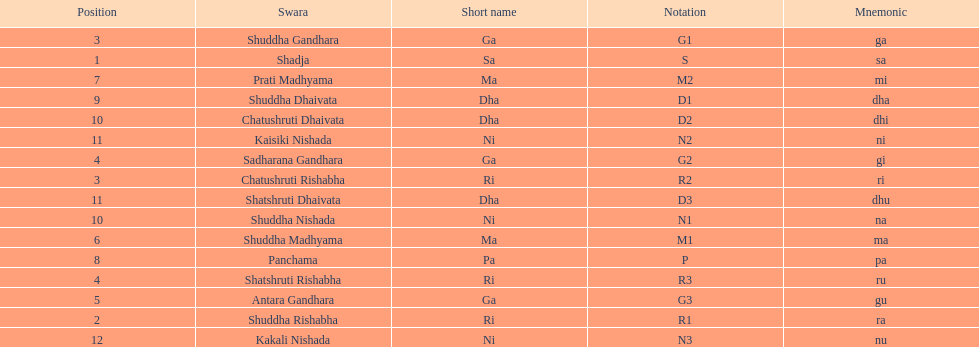What is the name of the swara that comes after panchama? Shuddha Dhaivata. 